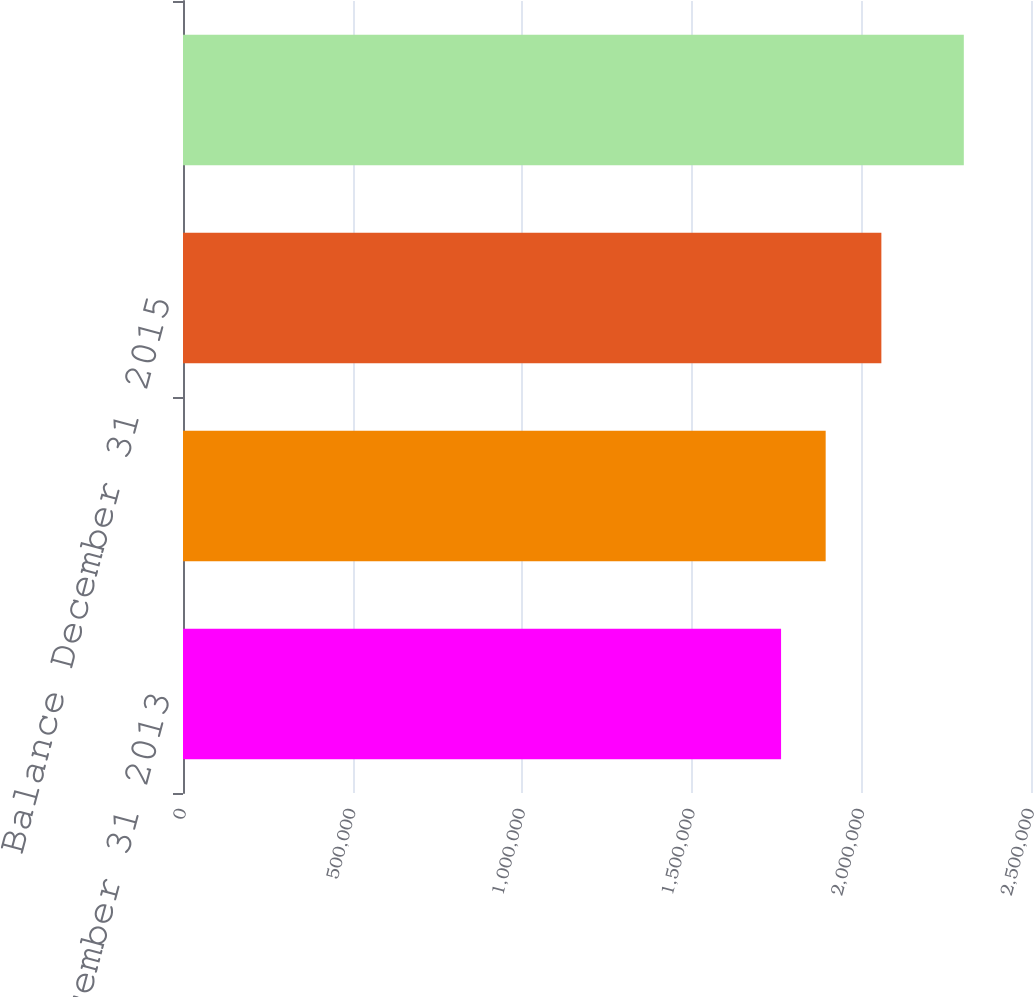<chart> <loc_0><loc_0><loc_500><loc_500><bar_chart><fcel>Balance December 31 2013<fcel>Balance December 31 2014<fcel>Balance December 31 2015<fcel>Balance December 31 2016<nl><fcel>1.76317e+06<fcel>1.89467e+06<fcel>2.05885e+06<fcel>2.30195e+06<nl></chart> 